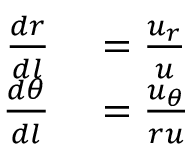<formula> <loc_0><loc_0><loc_500><loc_500>\begin{array} { r l } { \frac { d r } { d l } } & = \frac { u _ { r } } { u } } \\ { \frac { d \theta } { d l } } & = \frac { u _ { \theta } } { r u } } \end{array}</formula> 